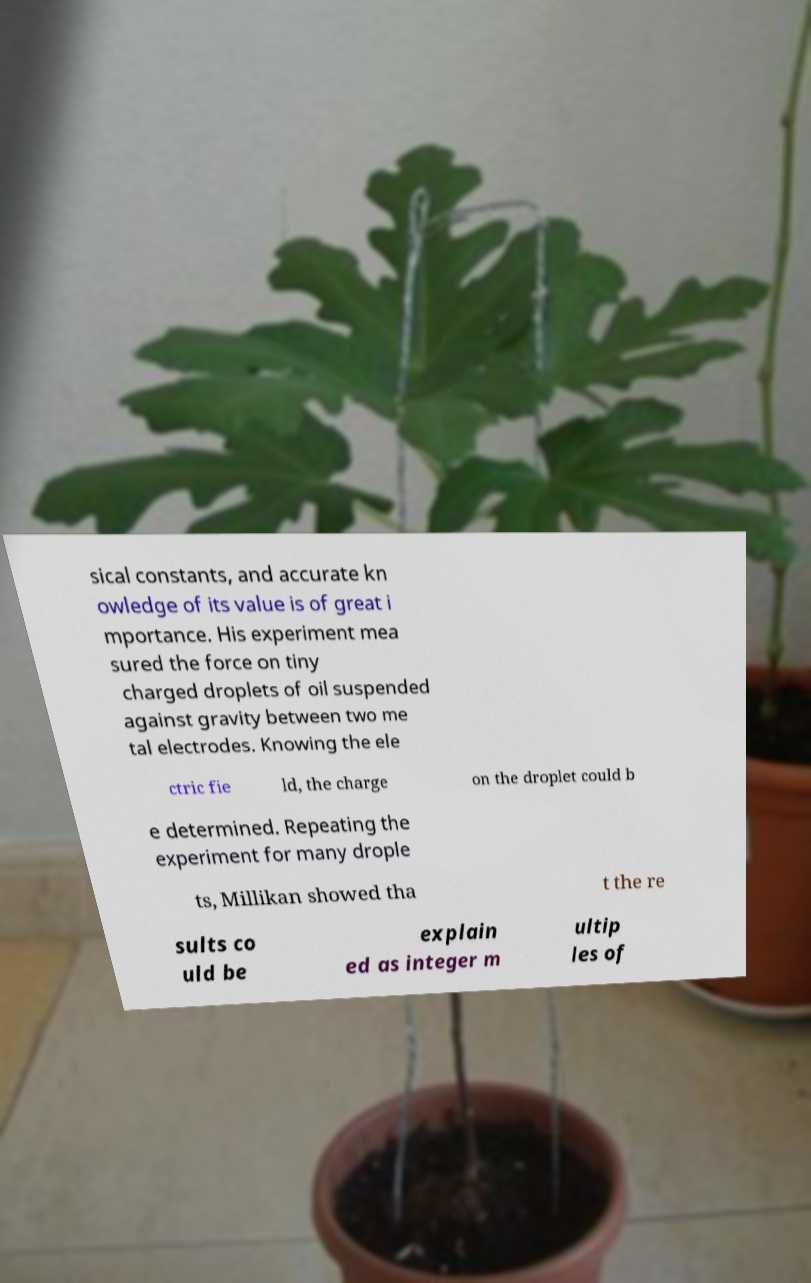There's text embedded in this image that I need extracted. Can you transcribe it verbatim? sical constants, and accurate kn owledge of its value is of great i mportance. His experiment mea sured the force on tiny charged droplets of oil suspended against gravity between two me tal electrodes. Knowing the ele ctric fie ld, the charge on the droplet could b e determined. Repeating the experiment for many drople ts, Millikan showed tha t the re sults co uld be explain ed as integer m ultip les of 